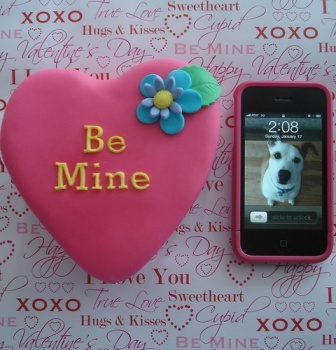Describe the following image. The image presents a charming scene, likely set around Valentine's Day. The main focus is a pink heart-shaped cookie, adorned with the words "Be Mine" in vibrant red icing. A small flower, with petals in hues of blue, purple, and yellow, adds a touch of whimsy to the cookie.

Beside the cookie, there's a pink iPhone displaying a photo of a white dog, adding a personal touch to the scene. The background is a white paper, but it's far from plain. It's scattered with red and pink words and phrases that evoke the spirit of Valentine's Day. Terms like "XOXO" and "Sweetheart" can be seen, further enhancing the festive atmosphere.

The objects are arranged in close proximity, with the cookie and the iPhone lying next to each other on the paper. The cookie, with its bold color and central placement, seems to be the star of the show. The iPhone, with its adorable dog photo, plays a supporting role, while the background paper sets the stage for this Valentine's Day tableau. The overall arrangement is harmonious and balanced, creating a pleasing visual composition. 